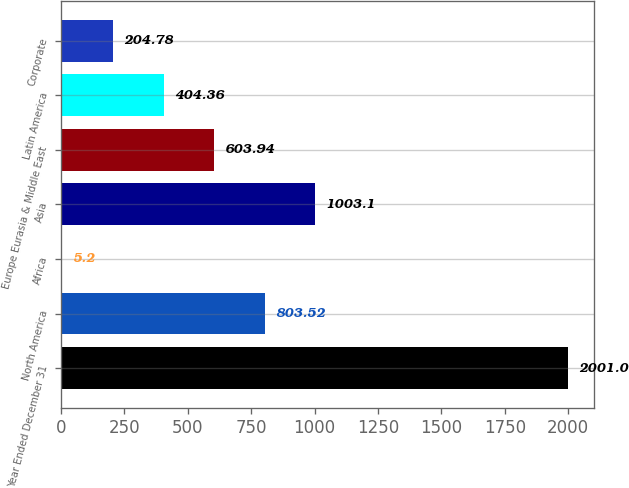Convert chart to OTSL. <chart><loc_0><loc_0><loc_500><loc_500><bar_chart><fcel>Year Ended December 31<fcel>North America<fcel>Africa<fcel>Asia<fcel>Europe Eurasia & Middle East<fcel>Latin America<fcel>Corporate<nl><fcel>2001<fcel>803.52<fcel>5.2<fcel>1003.1<fcel>603.94<fcel>404.36<fcel>204.78<nl></chart> 